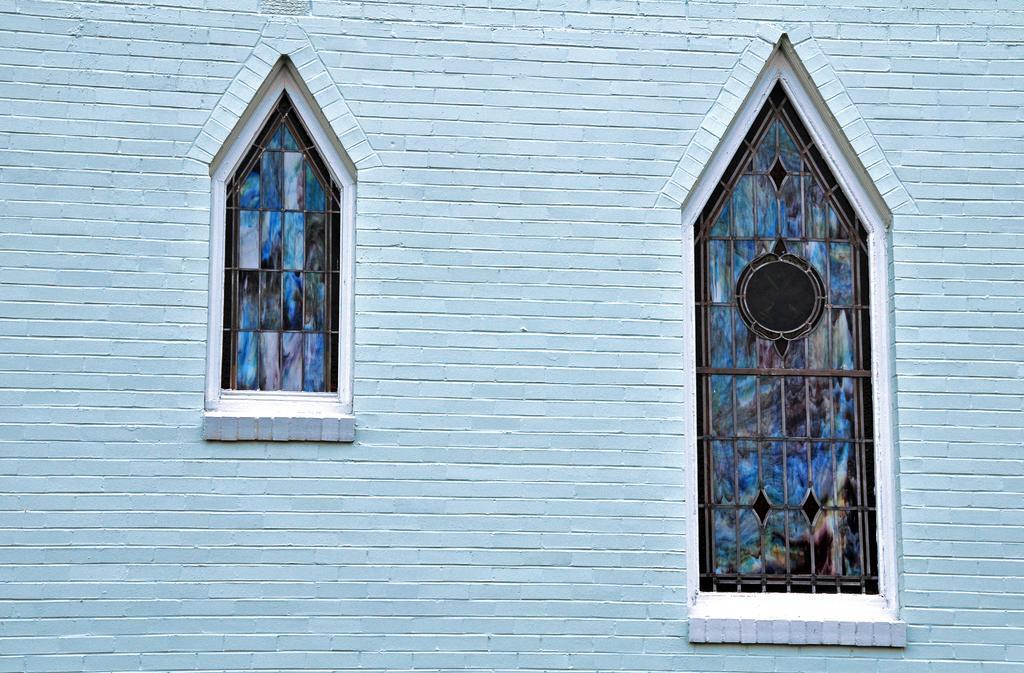Describe this image in one or two sentences. In the picture there is a wall, on the wall there are two glass windows present. 